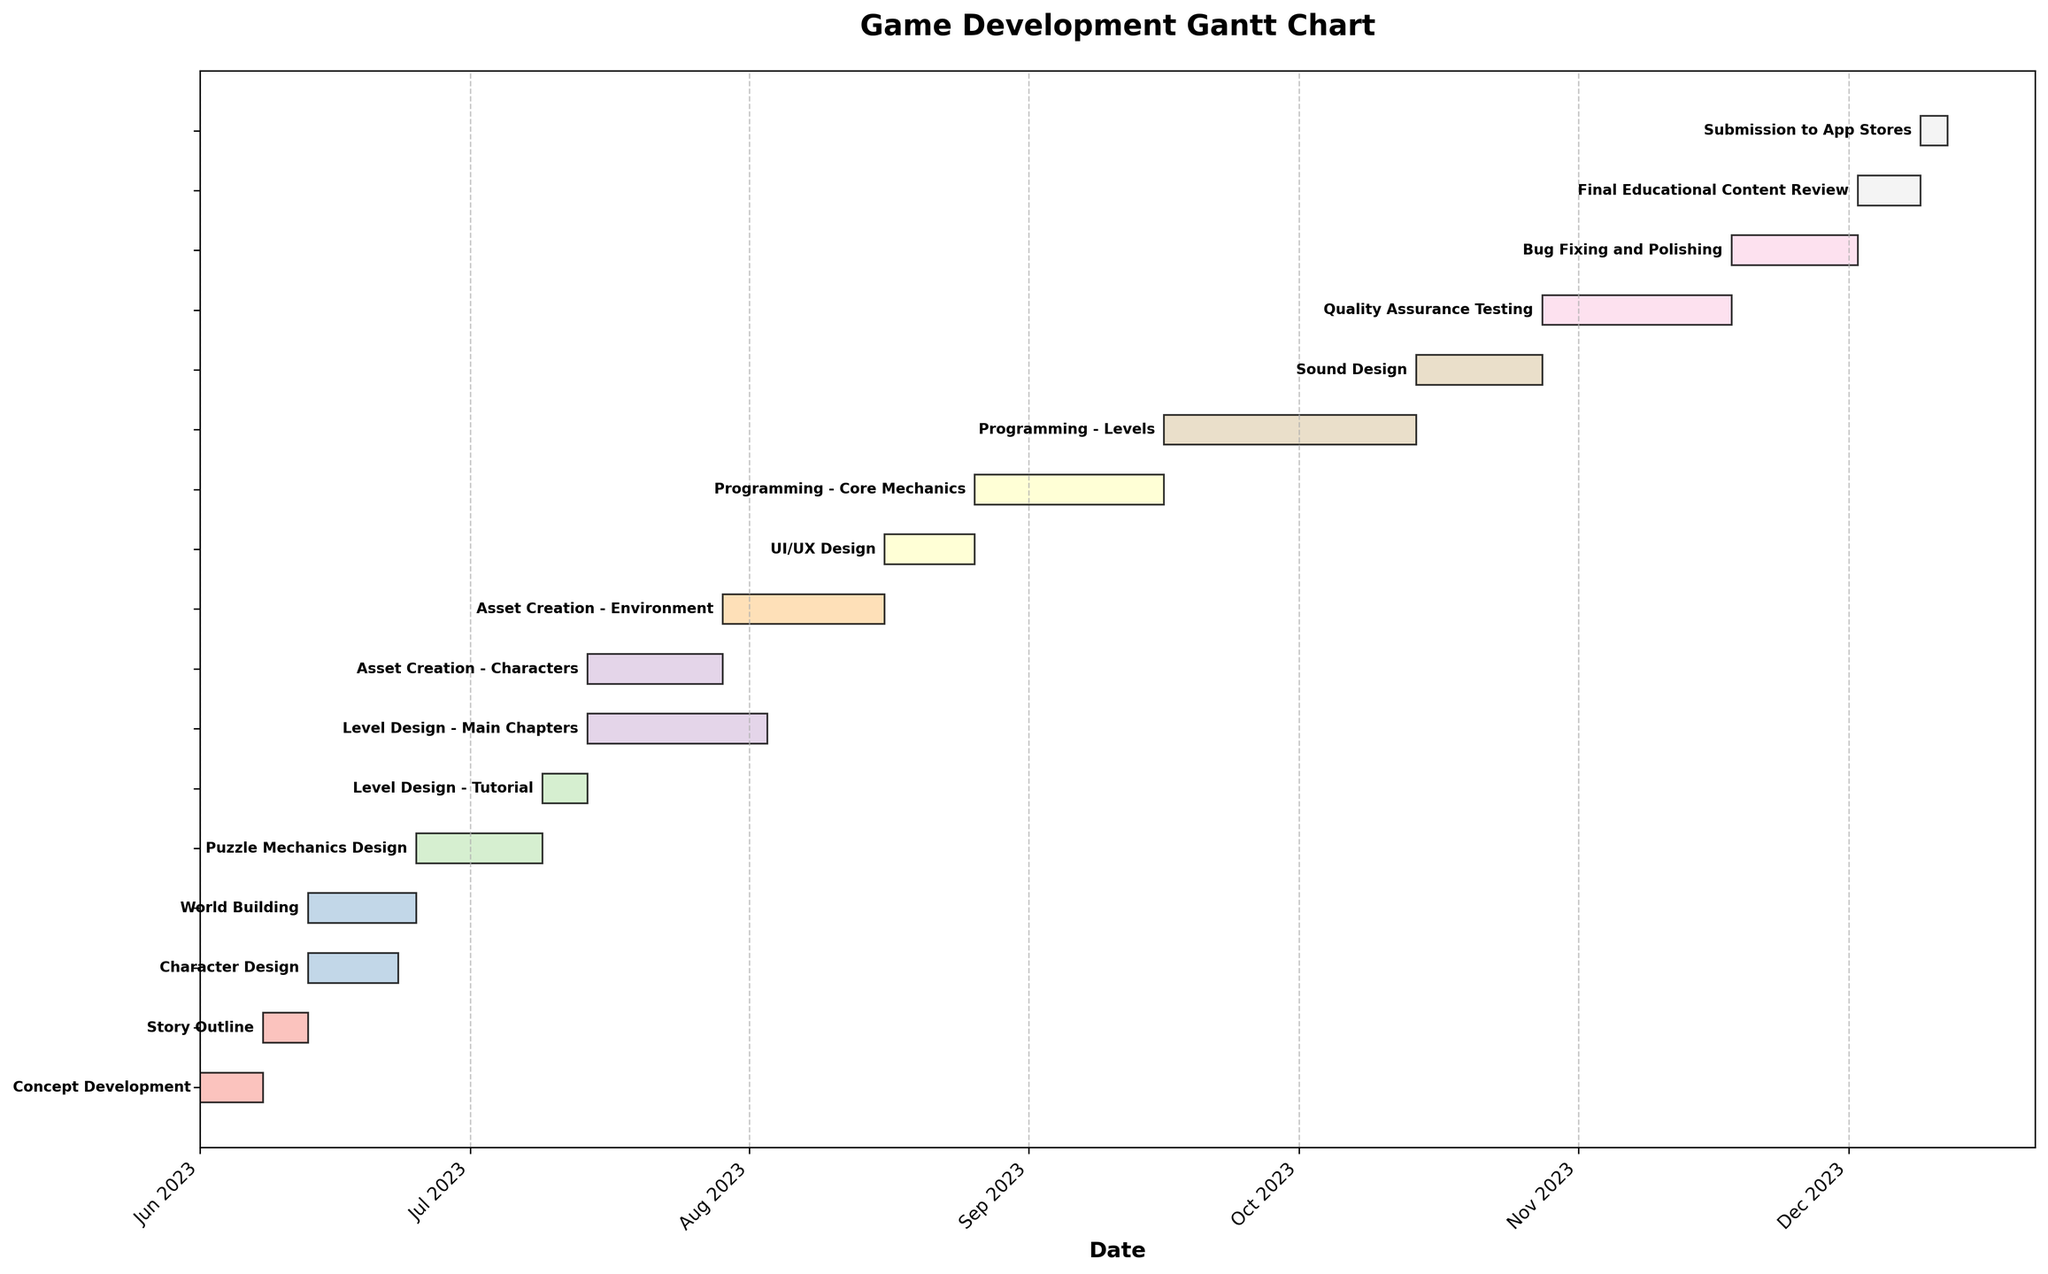What is the title of the Gantt Chart? The title of the chart is displayed prominently at the top, usually in a larger and bold font for clarity.
Answer: Game Development Gantt Chart How long does the "Story Outline" task take? The duration of the "Story Outline" task is identified by the length of the bar corresponding to that task. The duration in days is provided in the data, and can be visually confirmed using the date axis.
Answer: 5 days Which task starts immediately after "Level Design - Tutorial"? Look for the task that is placed beside "Level Design - Tutorial" on the Gantt chart. Check the start date of this task to ensure it directly follows the end date of "Level Design - Tutorial".
Answer: Level Design - Main Chapters How many tasks are dependent on "World Building"? Count the bars that have dependencies listed as "World Building" in the data, and visually confirm these dependencies by the connecting lines or bars.
Answer: 2 tasks What is the end date of the "Programming - Levels" task? To find the end date, add the duration of the "Programming - Levels" task to its start date, which can be read from the chart.
Answer: 2023-10-14 Which task takes the longest duration to complete? The task with the longest bar on the Gantt chart corresponds to the longest duration. Confirm by comparing the length of all tasks visible on the chart.
Answer: Programming - Levels How much time is required between the completion of "Character Design" and the start of "Asset Creation - Characters"? Identify the end date of "Character Design" and the start date of "Asset Creation - Characters" from the chart, and compute the number of days between these dates.
Answer: 1 day During which month does the "Final Educational Content Review" task start? Locate the "Final Educational Content Review" task on the chart and observe which month its start date falls into using the date axis at the top of the Gantt chart.
Answer: December 2023 Which task directly follows "Quality Assurance Testing"? Find the task that is scheduled to start immediately after "Quality Assurance Testing" based on the Gantt chart. Ensure its start date follows the end date of "Quality Assurance Testing".
Answer: Bug Fixing and Polishing Compare the duration of "UI/UX Design" and "Sound Design". Which one takes longer? Identify the durations of both "UI/UX Design" and "Sound Design" from the chart and compare these durations to determine which one is longer.
Answer: Programming - Levels 